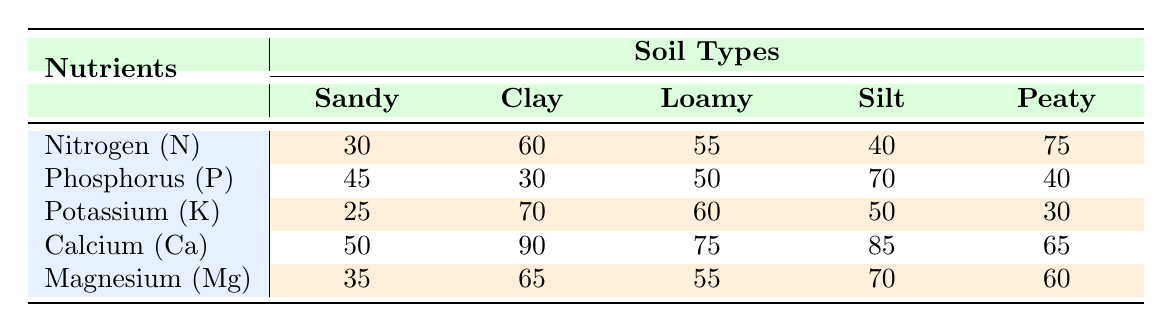What is the absorption rate of Nitrogen in Sandy soil? The table shows the absorption rate of Nitrogen (N) for Sandy soil as 30.
Answer: 30 Which soil type has the highest absorption rate for Phosphorus? From the table, Silt has the highest absorption rate for Phosphorus (P) at 70.
Answer: Silt What is the average absorption rate of Potassium across all soil types? To find the average, sum the absorption rates of Potassium for all soil types: (25 + 70 + 60 + 50 + 30) = 235. There are 5 soil types, so the average is 235/5 = 47.
Answer: 47 Is the Potassium absorption rate higher in Clay than in Peaty soil? The absorption rate of Potassium in Clay is 70, while in Peaty it is 30. Since 70 > 30, the statement is true.
Answer: Yes Which nutrient has the lowest average absorption rate across all soil types? To find the average for each nutrient, sum the absorption rates and divide by 5: Nitrogen: (30 + 60 + 55 + 40 + 75) = 260/5 = 52; Phosphorus: (45 + 30 + 50 + 70 + 40) = 235/5 = 47; Potassium: (25 + 70 + 60 + 50 + 30) = 235/5 = 47; Calcium: (50 + 90 + 75 + 85 + 65) = 365/5 = 73; Magnesium: (35 + 65 + 55 + 70 + 60) = 285/5 = 57. The lowest average is for Phosphorus at 47.
Answer: Phosphorus If we only consider Clay and Loamy soils, which nutrient is absorbed more in Clay than in Loamy? Looking at the table, the absorption rates for each nutrient in Clay and Loamy are: Nitrogen: 60 vs 55, Potassium: 70 vs 60, and Magnesium: 65 vs 55. Clay absorbs more Nitrogen, Potassium, and Magnesium than Loamy.
Answer: Nitrogen, Potassium, Magnesium 